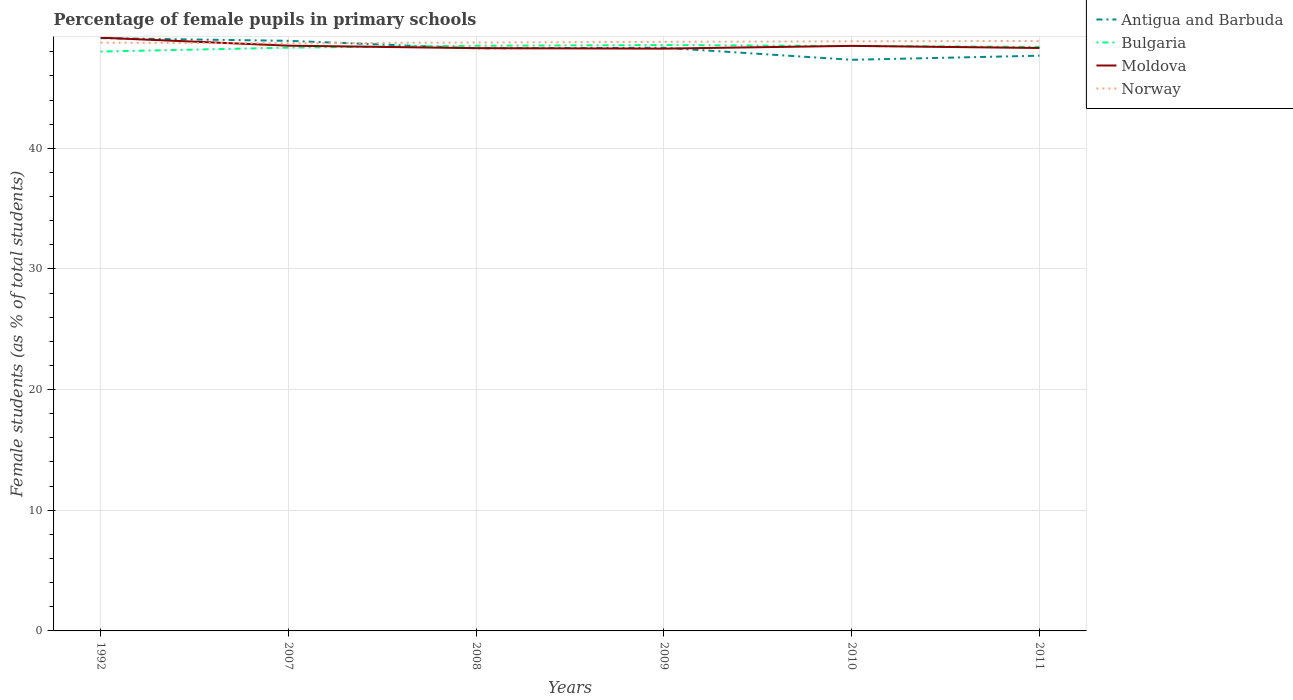How many different coloured lines are there?
Offer a very short reply. 4. Does the line corresponding to Moldova intersect with the line corresponding to Norway?
Offer a terse response. Yes. Across all years, what is the maximum percentage of female pupils in primary schools in Norway?
Your answer should be very brief. 48.7. In which year was the percentage of female pupils in primary schools in Bulgaria maximum?
Ensure brevity in your answer.  1992. What is the total percentage of female pupils in primary schools in Antigua and Barbuda in the graph?
Your answer should be very brief. 1.23. What is the difference between the highest and the second highest percentage of female pupils in primary schools in Antigua and Barbuda?
Your answer should be very brief. 1.79. What is the difference between the highest and the lowest percentage of female pupils in primary schools in Norway?
Your answer should be very brief. 3. Is the percentage of female pupils in primary schools in Norway strictly greater than the percentage of female pupils in primary schools in Moldova over the years?
Your answer should be compact. No. What is the difference between two consecutive major ticks on the Y-axis?
Provide a succinct answer. 10. Are the values on the major ticks of Y-axis written in scientific E-notation?
Keep it short and to the point. No. Does the graph contain any zero values?
Give a very brief answer. No. Does the graph contain grids?
Your response must be concise. Yes. Where does the legend appear in the graph?
Offer a terse response. Top right. How many legend labels are there?
Give a very brief answer. 4. What is the title of the graph?
Keep it short and to the point. Percentage of female pupils in primary schools. What is the label or title of the X-axis?
Your answer should be very brief. Years. What is the label or title of the Y-axis?
Make the answer very short. Female students (as % of total students). What is the Female students (as % of total students) in Antigua and Barbuda in 1992?
Your response must be concise. 49.13. What is the Female students (as % of total students) of Bulgaria in 1992?
Your response must be concise. 48.02. What is the Female students (as % of total students) of Moldova in 1992?
Your response must be concise. 49.17. What is the Female students (as % of total students) in Norway in 1992?
Offer a very short reply. 48.76. What is the Female students (as % of total students) in Antigua and Barbuda in 2007?
Make the answer very short. 48.91. What is the Female students (as % of total students) in Bulgaria in 2007?
Offer a very short reply. 48.34. What is the Female students (as % of total students) of Moldova in 2007?
Provide a succinct answer. 48.5. What is the Female students (as % of total students) in Norway in 2007?
Offer a very short reply. 48.7. What is the Female students (as % of total students) in Antigua and Barbuda in 2008?
Make the answer very short. 48.29. What is the Female students (as % of total students) of Bulgaria in 2008?
Your answer should be compact. 48.5. What is the Female students (as % of total students) in Moldova in 2008?
Give a very brief answer. 48.3. What is the Female students (as % of total students) of Norway in 2008?
Give a very brief answer. 48.77. What is the Female students (as % of total students) in Antigua and Barbuda in 2009?
Your answer should be very brief. 48.33. What is the Female students (as % of total students) in Bulgaria in 2009?
Your answer should be compact. 48.56. What is the Female students (as % of total students) in Moldova in 2009?
Ensure brevity in your answer.  48.26. What is the Female students (as % of total students) of Norway in 2009?
Provide a succinct answer. 48.82. What is the Female students (as % of total students) of Antigua and Barbuda in 2010?
Keep it short and to the point. 47.33. What is the Female students (as % of total students) of Bulgaria in 2010?
Keep it short and to the point. 48.48. What is the Female students (as % of total students) of Moldova in 2010?
Offer a terse response. 48.49. What is the Female students (as % of total students) in Norway in 2010?
Keep it short and to the point. 48.87. What is the Female students (as % of total students) in Antigua and Barbuda in 2011?
Offer a terse response. 47.67. What is the Female students (as % of total students) of Bulgaria in 2011?
Offer a terse response. 48.4. What is the Female students (as % of total students) in Moldova in 2011?
Offer a very short reply. 48.31. What is the Female students (as % of total students) in Norway in 2011?
Offer a very short reply. 48.9. Across all years, what is the maximum Female students (as % of total students) of Antigua and Barbuda?
Ensure brevity in your answer.  49.13. Across all years, what is the maximum Female students (as % of total students) in Bulgaria?
Give a very brief answer. 48.56. Across all years, what is the maximum Female students (as % of total students) in Moldova?
Offer a very short reply. 49.17. Across all years, what is the maximum Female students (as % of total students) in Norway?
Your response must be concise. 48.9. Across all years, what is the minimum Female students (as % of total students) of Antigua and Barbuda?
Offer a very short reply. 47.33. Across all years, what is the minimum Female students (as % of total students) in Bulgaria?
Offer a terse response. 48.02. Across all years, what is the minimum Female students (as % of total students) of Moldova?
Keep it short and to the point. 48.26. Across all years, what is the minimum Female students (as % of total students) in Norway?
Ensure brevity in your answer.  48.7. What is the total Female students (as % of total students) in Antigua and Barbuda in the graph?
Your response must be concise. 289.66. What is the total Female students (as % of total students) of Bulgaria in the graph?
Your response must be concise. 290.3. What is the total Female students (as % of total students) in Moldova in the graph?
Offer a terse response. 291.03. What is the total Female students (as % of total students) of Norway in the graph?
Your answer should be compact. 292.81. What is the difference between the Female students (as % of total students) of Antigua and Barbuda in 1992 and that in 2007?
Your answer should be compact. 0.22. What is the difference between the Female students (as % of total students) of Bulgaria in 1992 and that in 2007?
Keep it short and to the point. -0.32. What is the difference between the Female students (as % of total students) in Moldova in 1992 and that in 2007?
Your answer should be compact. 0.66. What is the difference between the Female students (as % of total students) of Norway in 1992 and that in 2007?
Give a very brief answer. 0.05. What is the difference between the Female students (as % of total students) of Antigua and Barbuda in 1992 and that in 2008?
Your answer should be compact. 0.84. What is the difference between the Female students (as % of total students) of Bulgaria in 1992 and that in 2008?
Your response must be concise. -0.48. What is the difference between the Female students (as % of total students) in Moldova in 1992 and that in 2008?
Provide a succinct answer. 0.87. What is the difference between the Female students (as % of total students) of Norway in 1992 and that in 2008?
Offer a terse response. -0.01. What is the difference between the Female students (as % of total students) of Antigua and Barbuda in 1992 and that in 2009?
Give a very brief answer. 0.8. What is the difference between the Female students (as % of total students) of Bulgaria in 1992 and that in 2009?
Offer a terse response. -0.54. What is the difference between the Female students (as % of total students) in Moldova in 1992 and that in 2009?
Give a very brief answer. 0.91. What is the difference between the Female students (as % of total students) of Norway in 1992 and that in 2009?
Make the answer very short. -0.07. What is the difference between the Female students (as % of total students) in Antigua and Barbuda in 1992 and that in 2010?
Your response must be concise. 1.79. What is the difference between the Female students (as % of total students) of Bulgaria in 1992 and that in 2010?
Make the answer very short. -0.46. What is the difference between the Female students (as % of total students) in Moldova in 1992 and that in 2010?
Your response must be concise. 0.68. What is the difference between the Female students (as % of total students) of Norway in 1992 and that in 2010?
Provide a succinct answer. -0.11. What is the difference between the Female students (as % of total students) in Antigua and Barbuda in 1992 and that in 2011?
Your response must be concise. 1.46. What is the difference between the Female students (as % of total students) in Bulgaria in 1992 and that in 2011?
Keep it short and to the point. -0.39. What is the difference between the Female students (as % of total students) in Moldova in 1992 and that in 2011?
Your answer should be compact. 0.85. What is the difference between the Female students (as % of total students) of Norway in 1992 and that in 2011?
Offer a terse response. -0.14. What is the difference between the Female students (as % of total students) in Antigua and Barbuda in 2007 and that in 2008?
Offer a very short reply. 0.62. What is the difference between the Female students (as % of total students) of Bulgaria in 2007 and that in 2008?
Ensure brevity in your answer.  -0.16. What is the difference between the Female students (as % of total students) of Moldova in 2007 and that in 2008?
Your answer should be very brief. 0.21. What is the difference between the Female students (as % of total students) in Norway in 2007 and that in 2008?
Offer a very short reply. -0.06. What is the difference between the Female students (as % of total students) in Antigua and Barbuda in 2007 and that in 2009?
Offer a very short reply. 0.57. What is the difference between the Female students (as % of total students) in Bulgaria in 2007 and that in 2009?
Your answer should be compact. -0.22. What is the difference between the Female students (as % of total students) of Moldova in 2007 and that in 2009?
Offer a terse response. 0.24. What is the difference between the Female students (as % of total students) in Norway in 2007 and that in 2009?
Give a very brief answer. -0.12. What is the difference between the Female students (as % of total students) of Antigua and Barbuda in 2007 and that in 2010?
Offer a terse response. 1.57. What is the difference between the Female students (as % of total students) of Bulgaria in 2007 and that in 2010?
Keep it short and to the point. -0.14. What is the difference between the Female students (as % of total students) in Moldova in 2007 and that in 2010?
Provide a succinct answer. 0.02. What is the difference between the Female students (as % of total students) in Norway in 2007 and that in 2010?
Your answer should be very brief. -0.17. What is the difference between the Female students (as % of total students) in Antigua and Barbuda in 2007 and that in 2011?
Keep it short and to the point. 1.23. What is the difference between the Female students (as % of total students) in Bulgaria in 2007 and that in 2011?
Your response must be concise. -0.07. What is the difference between the Female students (as % of total students) of Moldova in 2007 and that in 2011?
Give a very brief answer. 0.19. What is the difference between the Female students (as % of total students) of Norway in 2007 and that in 2011?
Make the answer very short. -0.19. What is the difference between the Female students (as % of total students) of Antigua and Barbuda in 2008 and that in 2009?
Offer a terse response. -0.05. What is the difference between the Female students (as % of total students) in Bulgaria in 2008 and that in 2009?
Offer a very short reply. -0.06. What is the difference between the Female students (as % of total students) of Moldova in 2008 and that in 2009?
Keep it short and to the point. 0.04. What is the difference between the Female students (as % of total students) of Norway in 2008 and that in 2009?
Offer a terse response. -0.06. What is the difference between the Female students (as % of total students) of Antigua and Barbuda in 2008 and that in 2010?
Your response must be concise. 0.95. What is the difference between the Female students (as % of total students) of Bulgaria in 2008 and that in 2010?
Make the answer very short. 0.02. What is the difference between the Female students (as % of total students) of Moldova in 2008 and that in 2010?
Make the answer very short. -0.19. What is the difference between the Female students (as % of total students) in Norway in 2008 and that in 2010?
Make the answer very short. -0.1. What is the difference between the Female students (as % of total students) in Antigua and Barbuda in 2008 and that in 2011?
Give a very brief answer. 0.61. What is the difference between the Female students (as % of total students) of Bulgaria in 2008 and that in 2011?
Keep it short and to the point. 0.1. What is the difference between the Female students (as % of total students) in Moldova in 2008 and that in 2011?
Ensure brevity in your answer.  -0.01. What is the difference between the Female students (as % of total students) in Norway in 2008 and that in 2011?
Provide a short and direct response. -0.13. What is the difference between the Female students (as % of total students) of Bulgaria in 2009 and that in 2010?
Make the answer very short. 0.08. What is the difference between the Female students (as % of total students) of Moldova in 2009 and that in 2010?
Ensure brevity in your answer.  -0.23. What is the difference between the Female students (as % of total students) of Norway in 2009 and that in 2010?
Keep it short and to the point. -0.05. What is the difference between the Female students (as % of total students) in Antigua and Barbuda in 2009 and that in 2011?
Make the answer very short. 0.66. What is the difference between the Female students (as % of total students) in Bulgaria in 2009 and that in 2011?
Your answer should be compact. 0.15. What is the difference between the Female students (as % of total students) of Moldova in 2009 and that in 2011?
Ensure brevity in your answer.  -0.05. What is the difference between the Female students (as % of total students) of Norway in 2009 and that in 2011?
Provide a short and direct response. -0.07. What is the difference between the Female students (as % of total students) of Antigua and Barbuda in 2010 and that in 2011?
Give a very brief answer. -0.34. What is the difference between the Female students (as % of total students) in Bulgaria in 2010 and that in 2011?
Offer a terse response. 0.07. What is the difference between the Female students (as % of total students) in Moldova in 2010 and that in 2011?
Offer a terse response. 0.17. What is the difference between the Female students (as % of total students) in Norway in 2010 and that in 2011?
Your answer should be compact. -0.03. What is the difference between the Female students (as % of total students) of Antigua and Barbuda in 1992 and the Female students (as % of total students) of Bulgaria in 2007?
Your response must be concise. 0.79. What is the difference between the Female students (as % of total students) in Antigua and Barbuda in 1992 and the Female students (as % of total students) in Moldova in 2007?
Make the answer very short. 0.62. What is the difference between the Female students (as % of total students) of Antigua and Barbuda in 1992 and the Female students (as % of total students) of Norway in 2007?
Provide a succinct answer. 0.43. What is the difference between the Female students (as % of total students) of Bulgaria in 1992 and the Female students (as % of total students) of Moldova in 2007?
Provide a short and direct response. -0.49. What is the difference between the Female students (as % of total students) of Bulgaria in 1992 and the Female students (as % of total students) of Norway in 2007?
Offer a terse response. -0.68. What is the difference between the Female students (as % of total students) of Moldova in 1992 and the Female students (as % of total students) of Norway in 2007?
Your answer should be compact. 0.46. What is the difference between the Female students (as % of total students) of Antigua and Barbuda in 1992 and the Female students (as % of total students) of Bulgaria in 2008?
Offer a very short reply. 0.63. What is the difference between the Female students (as % of total students) of Antigua and Barbuda in 1992 and the Female students (as % of total students) of Moldova in 2008?
Give a very brief answer. 0.83. What is the difference between the Female students (as % of total students) in Antigua and Barbuda in 1992 and the Female students (as % of total students) in Norway in 2008?
Offer a very short reply. 0.36. What is the difference between the Female students (as % of total students) in Bulgaria in 1992 and the Female students (as % of total students) in Moldova in 2008?
Offer a terse response. -0.28. What is the difference between the Female students (as % of total students) in Bulgaria in 1992 and the Female students (as % of total students) in Norway in 2008?
Offer a terse response. -0.75. What is the difference between the Female students (as % of total students) of Moldova in 1992 and the Female students (as % of total students) of Norway in 2008?
Offer a terse response. 0.4. What is the difference between the Female students (as % of total students) of Antigua and Barbuda in 1992 and the Female students (as % of total students) of Bulgaria in 2009?
Give a very brief answer. 0.57. What is the difference between the Female students (as % of total students) in Antigua and Barbuda in 1992 and the Female students (as % of total students) in Moldova in 2009?
Give a very brief answer. 0.87. What is the difference between the Female students (as % of total students) in Antigua and Barbuda in 1992 and the Female students (as % of total students) in Norway in 2009?
Give a very brief answer. 0.31. What is the difference between the Female students (as % of total students) of Bulgaria in 1992 and the Female students (as % of total students) of Moldova in 2009?
Keep it short and to the point. -0.24. What is the difference between the Female students (as % of total students) in Bulgaria in 1992 and the Female students (as % of total students) in Norway in 2009?
Offer a very short reply. -0.8. What is the difference between the Female students (as % of total students) in Moldova in 1992 and the Female students (as % of total students) in Norway in 2009?
Keep it short and to the point. 0.34. What is the difference between the Female students (as % of total students) in Antigua and Barbuda in 1992 and the Female students (as % of total students) in Bulgaria in 2010?
Ensure brevity in your answer.  0.65. What is the difference between the Female students (as % of total students) in Antigua and Barbuda in 1992 and the Female students (as % of total students) in Moldova in 2010?
Make the answer very short. 0.64. What is the difference between the Female students (as % of total students) in Antigua and Barbuda in 1992 and the Female students (as % of total students) in Norway in 2010?
Make the answer very short. 0.26. What is the difference between the Female students (as % of total students) in Bulgaria in 1992 and the Female students (as % of total students) in Moldova in 2010?
Your answer should be very brief. -0.47. What is the difference between the Female students (as % of total students) in Bulgaria in 1992 and the Female students (as % of total students) in Norway in 2010?
Offer a very short reply. -0.85. What is the difference between the Female students (as % of total students) of Moldova in 1992 and the Female students (as % of total students) of Norway in 2010?
Your response must be concise. 0.3. What is the difference between the Female students (as % of total students) in Antigua and Barbuda in 1992 and the Female students (as % of total students) in Bulgaria in 2011?
Give a very brief answer. 0.72. What is the difference between the Female students (as % of total students) in Antigua and Barbuda in 1992 and the Female students (as % of total students) in Moldova in 2011?
Your answer should be very brief. 0.82. What is the difference between the Female students (as % of total students) in Antigua and Barbuda in 1992 and the Female students (as % of total students) in Norway in 2011?
Offer a terse response. 0.23. What is the difference between the Female students (as % of total students) of Bulgaria in 1992 and the Female students (as % of total students) of Moldova in 2011?
Your answer should be compact. -0.29. What is the difference between the Female students (as % of total students) of Bulgaria in 1992 and the Female students (as % of total students) of Norway in 2011?
Provide a succinct answer. -0.88. What is the difference between the Female students (as % of total students) in Moldova in 1992 and the Female students (as % of total students) in Norway in 2011?
Your response must be concise. 0.27. What is the difference between the Female students (as % of total students) in Antigua and Barbuda in 2007 and the Female students (as % of total students) in Bulgaria in 2008?
Provide a short and direct response. 0.41. What is the difference between the Female students (as % of total students) of Antigua and Barbuda in 2007 and the Female students (as % of total students) of Moldova in 2008?
Provide a short and direct response. 0.61. What is the difference between the Female students (as % of total students) in Antigua and Barbuda in 2007 and the Female students (as % of total students) in Norway in 2008?
Provide a succinct answer. 0.14. What is the difference between the Female students (as % of total students) in Bulgaria in 2007 and the Female students (as % of total students) in Moldova in 2008?
Your response must be concise. 0.04. What is the difference between the Female students (as % of total students) of Bulgaria in 2007 and the Female students (as % of total students) of Norway in 2008?
Offer a terse response. -0.43. What is the difference between the Female students (as % of total students) of Moldova in 2007 and the Female students (as % of total students) of Norway in 2008?
Offer a very short reply. -0.26. What is the difference between the Female students (as % of total students) in Antigua and Barbuda in 2007 and the Female students (as % of total students) in Bulgaria in 2009?
Keep it short and to the point. 0.35. What is the difference between the Female students (as % of total students) in Antigua and Barbuda in 2007 and the Female students (as % of total students) in Moldova in 2009?
Your answer should be very brief. 0.65. What is the difference between the Female students (as % of total students) in Antigua and Barbuda in 2007 and the Female students (as % of total students) in Norway in 2009?
Your response must be concise. 0.08. What is the difference between the Female students (as % of total students) in Bulgaria in 2007 and the Female students (as % of total students) in Moldova in 2009?
Keep it short and to the point. 0.08. What is the difference between the Female students (as % of total students) in Bulgaria in 2007 and the Female students (as % of total students) in Norway in 2009?
Your answer should be very brief. -0.48. What is the difference between the Female students (as % of total students) of Moldova in 2007 and the Female students (as % of total students) of Norway in 2009?
Ensure brevity in your answer.  -0.32. What is the difference between the Female students (as % of total students) in Antigua and Barbuda in 2007 and the Female students (as % of total students) in Bulgaria in 2010?
Your answer should be compact. 0.43. What is the difference between the Female students (as % of total students) of Antigua and Barbuda in 2007 and the Female students (as % of total students) of Moldova in 2010?
Offer a terse response. 0.42. What is the difference between the Female students (as % of total students) in Antigua and Barbuda in 2007 and the Female students (as % of total students) in Norway in 2010?
Give a very brief answer. 0.04. What is the difference between the Female students (as % of total students) in Bulgaria in 2007 and the Female students (as % of total students) in Moldova in 2010?
Give a very brief answer. -0.15. What is the difference between the Female students (as % of total students) of Bulgaria in 2007 and the Female students (as % of total students) of Norway in 2010?
Keep it short and to the point. -0.53. What is the difference between the Female students (as % of total students) in Moldova in 2007 and the Female students (as % of total students) in Norway in 2010?
Give a very brief answer. -0.36. What is the difference between the Female students (as % of total students) in Antigua and Barbuda in 2007 and the Female students (as % of total students) in Bulgaria in 2011?
Your answer should be compact. 0.5. What is the difference between the Female students (as % of total students) in Antigua and Barbuda in 2007 and the Female students (as % of total students) in Moldova in 2011?
Your response must be concise. 0.59. What is the difference between the Female students (as % of total students) of Antigua and Barbuda in 2007 and the Female students (as % of total students) of Norway in 2011?
Your answer should be very brief. 0.01. What is the difference between the Female students (as % of total students) in Bulgaria in 2007 and the Female students (as % of total students) in Moldova in 2011?
Offer a very short reply. 0.03. What is the difference between the Female students (as % of total students) of Bulgaria in 2007 and the Female students (as % of total students) of Norway in 2011?
Your answer should be very brief. -0.56. What is the difference between the Female students (as % of total students) of Moldova in 2007 and the Female students (as % of total students) of Norway in 2011?
Your response must be concise. -0.39. What is the difference between the Female students (as % of total students) in Antigua and Barbuda in 2008 and the Female students (as % of total students) in Bulgaria in 2009?
Make the answer very short. -0.27. What is the difference between the Female students (as % of total students) in Antigua and Barbuda in 2008 and the Female students (as % of total students) in Moldova in 2009?
Ensure brevity in your answer.  0.03. What is the difference between the Female students (as % of total students) in Antigua and Barbuda in 2008 and the Female students (as % of total students) in Norway in 2009?
Give a very brief answer. -0.53. What is the difference between the Female students (as % of total students) in Bulgaria in 2008 and the Female students (as % of total students) in Moldova in 2009?
Make the answer very short. 0.24. What is the difference between the Female students (as % of total students) in Bulgaria in 2008 and the Female students (as % of total students) in Norway in 2009?
Keep it short and to the point. -0.32. What is the difference between the Female students (as % of total students) in Moldova in 2008 and the Female students (as % of total students) in Norway in 2009?
Provide a succinct answer. -0.52. What is the difference between the Female students (as % of total students) in Antigua and Barbuda in 2008 and the Female students (as % of total students) in Bulgaria in 2010?
Offer a very short reply. -0.19. What is the difference between the Female students (as % of total students) of Antigua and Barbuda in 2008 and the Female students (as % of total students) of Moldova in 2010?
Your answer should be very brief. -0.2. What is the difference between the Female students (as % of total students) in Antigua and Barbuda in 2008 and the Female students (as % of total students) in Norway in 2010?
Provide a succinct answer. -0.58. What is the difference between the Female students (as % of total students) of Bulgaria in 2008 and the Female students (as % of total students) of Moldova in 2010?
Your answer should be compact. 0.01. What is the difference between the Female students (as % of total students) in Bulgaria in 2008 and the Female students (as % of total students) in Norway in 2010?
Your answer should be compact. -0.37. What is the difference between the Female students (as % of total students) in Moldova in 2008 and the Female students (as % of total students) in Norway in 2010?
Offer a very short reply. -0.57. What is the difference between the Female students (as % of total students) in Antigua and Barbuda in 2008 and the Female students (as % of total students) in Bulgaria in 2011?
Keep it short and to the point. -0.12. What is the difference between the Female students (as % of total students) in Antigua and Barbuda in 2008 and the Female students (as % of total students) in Moldova in 2011?
Make the answer very short. -0.03. What is the difference between the Female students (as % of total students) of Antigua and Barbuda in 2008 and the Female students (as % of total students) of Norway in 2011?
Offer a very short reply. -0.61. What is the difference between the Female students (as % of total students) in Bulgaria in 2008 and the Female students (as % of total students) in Moldova in 2011?
Your answer should be compact. 0.19. What is the difference between the Female students (as % of total students) in Bulgaria in 2008 and the Female students (as % of total students) in Norway in 2011?
Provide a succinct answer. -0.4. What is the difference between the Female students (as % of total students) in Moldova in 2008 and the Female students (as % of total students) in Norway in 2011?
Ensure brevity in your answer.  -0.6. What is the difference between the Female students (as % of total students) of Antigua and Barbuda in 2009 and the Female students (as % of total students) of Bulgaria in 2010?
Offer a very short reply. -0.14. What is the difference between the Female students (as % of total students) of Antigua and Barbuda in 2009 and the Female students (as % of total students) of Moldova in 2010?
Ensure brevity in your answer.  -0.15. What is the difference between the Female students (as % of total students) in Antigua and Barbuda in 2009 and the Female students (as % of total students) in Norway in 2010?
Your answer should be very brief. -0.54. What is the difference between the Female students (as % of total students) of Bulgaria in 2009 and the Female students (as % of total students) of Moldova in 2010?
Provide a short and direct response. 0.07. What is the difference between the Female students (as % of total students) of Bulgaria in 2009 and the Female students (as % of total students) of Norway in 2010?
Give a very brief answer. -0.31. What is the difference between the Female students (as % of total students) in Moldova in 2009 and the Female students (as % of total students) in Norway in 2010?
Offer a terse response. -0.61. What is the difference between the Female students (as % of total students) in Antigua and Barbuda in 2009 and the Female students (as % of total students) in Bulgaria in 2011?
Provide a succinct answer. -0.07. What is the difference between the Female students (as % of total students) of Antigua and Barbuda in 2009 and the Female students (as % of total students) of Moldova in 2011?
Ensure brevity in your answer.  0.02. What is the difference between the Female students (as % of total students) in Antigua and Barbuda in 2009 and the Female students (as % of total students) in Norway in 2011?
Give a very brief answer. -0.56. What is the difference between the Female students (as % of total students) in Bulgaria in 2009 and the Female students (as % of total students) in Moldova in 2011?
Provide a short and direct response. 0.25. What is the difference between the Female students (as % of total students) in Bulgaria in 2009 and the Female students (as % of total students) in Norway in 2011?
Your answer should be very brief. -0.34. What is the difference between the Female students (as % of total students) of Moldova in 2009 and the Female students (as % of total students) of Norway in 2011?
Offer a terse response. -0.64. What is the difference between the Female students (as % of total students) of Antigua and Barbuda in 2010 and the Female students (as % of total students) of Bulgaria in 2011?
Make the answer very short. -1.07. What is the difference between the Female students (as % of total students) of Antigua and Barbuda in 2010 and the Female students (as % of total students) of Moldova in 2011?
Your response must be concise. -0.98. What is the difference between the Female students (as % of total students) of Antigua and Barbuda in 2010 and the Female students (as % of total students) of Norway in 2011?
Offer a very short reply. -1.56. What is the difference between the Female students (as % of total students) in Bulgaria in 2010 and the Female students (as % of total students) in Moldova in 2011?
Offer a very short reply. 0.16. What is the difference between the Female students (as % of total students) in Bulgaria in 2010 and the Female students (as % of total students) in Norway in 2011?
Your response must be concise. -0.42. What is the difference between the Female students (as % of total students) of Moldova in 2010 and the Female students (as % of total students) of Norway in 2011?
Provide a short and direct response. -0.41. What is the average Female students (as % of total students) of Antigua and Barbuda per year?
Give a very brief answer. 48.28. What is the average Female students (as % of total students) of Bulgaria per year?
Provide a succinct answer. 48.38. What is the average Female students (as % of total students) of Moldova per year?
Your response must be concise. 48.51. What is the average Female students (as % of total students) in Norway per year?
Your answer should be very brief. 48.8. In the year 1992, what is the difference between the Female students (as % of total students) of Antigua and Barbuda and Female students (as % of total students) of Bulgaria?
Offer a terse response. 1.11. In the year 1992, what is the difference between the Female students (as % of total students) of Antigua and Barbuda and Female students (as % of total students) of Moldova?
Your answer should be compact. -0.04. In the year 1992, what is the difference between the Female students (as % of total students) in Antigua and Barbuda and Female students (as % of total students) in Norway?
Make the answer very short. 0.37. In the year 1992, what is the difference between the Female students (as % of total students) in Bulgaria and Female students (as % of total students) in Moldova?
Give a very brief answer. -1.15. In the year 1992, what is the difference between the Female students (as % of total students) of Bulgaria and Female students (as % of total students) of Norway?
Your response must be concise. -0.74. In the year 1992, what is the difference between the Female students (as % of total students) in Moldova and Female students (as % of total students) in Norway?
Offer a terse response. 0.41. In the year 2007, what is the difference between the Female students (as % of total students) in Antigua and Barbuda and Female students (as % of total students) in Bulgaria?
Offer a terse response. 0.57. In the year 2007, what is the difference between the Female students (as % of total students) of Antigua and Barbuda and Female students (as % of total students) of Moldova?
Your answer should be compact. 0.4. In the year 2007, what is the difference between the Female students (as % of total students) of Antigua and Barbuda and Female students (as % of total students) of Norway?
Your answer should be very brief. 0.2. In the year 2007, what is the difference between the Female students (as % of total students) of Bulgaria and Female students (as % of total students) of Moldova?
Ensure brevity in your answer.  -0.17. In the year 2007, what is the difference between the Female students (as % of total students) in Bulgaria and Female students (as % of total students) in Norway?
Offer a very short reply. -0.36. In the year 2007, what is the difference between the Female students (as % of total students) of Moldova and Female students (as % of total students) of Norway?
Offer a terse response. -0.2. In the year 2008, what is the difference between the Female students (as % of total students) of Antigua and Barbuda and Female students (as % of total students) of Bulgaria?
Offer a very short reply. -0.21. In the year 2008, what is the difference between the Female students (as % of total students) in Antigua and Barbuda and Female students (as % of total students) in Moldova?
Your answer should be compact. -0.01. In the year 2008, what is the difference between the Female students (as % of total students) in Antigua and Barbuda and Female students (as % of total students) in Norway?
Your answer should be very brief. -0.48. In the year 2008, what is the difference between the Female students (as % of total students) of Bulgaria and Female students (as % of total students) of Moldova?
Ensure brevity in your answer.  0.2. In the year 2008, what is the difference between the Female students (as % of total students) in Bulgaria and Female students (as % of total students) in Norway?
Provide a succinct answer. -0.27. In the year 2008, what is the difference between the Female students (as % of total students) in Moldova and Female students (as % of total students) in Norway?
Provide a short and direct response. -0.47. In the year 2009, what is the difference between the Female students (as % of total students) in Antigua and Barbuda and Female students (as % of total students) in Bulgaria?
Provide a short and direct response. -0.23. In the year 2009, what is the difference between the Female students (as % of total students) in Antigua and Barbuda and Female students (as % of total students) in Moldova?
Keep it short and to the point. 0.07. In the year 2009, what is the difference between the Female students (as % of total students) in Antigua and Barbuda and Female students (as % of total students) in Norway?
Give a very brief answer. -0.49. In the year 2009, what is the difference between the Female students (as % of total students) in Bulgaria and Female students (as % of total students) in Moldova?
Your response must be concise. 0.3. In the year 2009, what is the difference between the Female students (as % of total students) in Bulgaria and Female students (as % of total students) in Norway?
Your answer should be compact. -0.26. In the year 2009, what is the difference between the Female students (as % of total students) of Moldova and Female students (as % of total students) of Norway?
Offer a very short reply. -0.56. In the year 2010, what is the difference between the Female students (as % of total students) of Antigua and Barbuda and Female students (as % of total students) of Bulgaria?
Your response must be concise. -1.14. In the year 2010, what is the difference between the Female students (as % of total students) in Antigua and Barbuda and Female students (as % of total students) in Moldova?
Make the answer very short. -1.15. In the year 2010, what is the difference between the Female students (as % of total students) in Antigua and Barbuda and Female students (as % of total students) in Norway?
Make the answer very short. -1.53. In the year 2010, what is the difference between the Female students (as % of total students) of Bulgaria and Female students (as % of total students) of Moldova?
Your response must be concise. -0.01. In the year 2010, what is the difference between the Female students (as % of total students) in Bulgaria and Female students (as % of total students) in Norway?
Your response must be concise. -0.39. In the year 2010, what is the difference between the Female students (as % of total students) of Moldova and Female students (as % of total students) of Norway?
Ensure brevity in your answer.  -0.38. In the year 2011, what is the difference between the Female students (as % of total students) of Antigua and Barbuda and Female students (as % of total students) of Bulgaria?
Ensure brevity in your answer.  -0.73. In the year 2011, what is the difference between the Female students (as % of total students) in Antigua and Barbuda and Female students (as % of total students) in Moldova?
Ensure brevity in your answer.  -0.64. In the year 2011, what is the difference between the Female students (as % of total students) in Antigua and Barbuda and Female students (as % of total students) in Norway?
Your answer should be compact. -1.22. In the year 2011, what is the difference between the Female students (as % of total students) of Bulgaria and Female students (as % of total students) of Moldova?
Give a very brief answer. 0.09. In the year 2011, what is the difference between the Female students (as % of total students) of Bulgaria and Female students (as % of total students) of Norway?
Offer a very short reply. -0.49. In the year 2011, what is the difference between the Female students (as % of total students) in Moldova and Female students (as % of total students) in Norway?
Offer a very short reply. -0.58. What is the ratio of the Female students (as % of total students) in Moldova in 1992 to that in 2007?
Keep it short and to the point. 1.01. What is the ratio of the Female students (as % of total students) in Norway in 1992 to that in 2007?
Keep it short and to the point. 1. What is the ratio of the Female students (as % of total students) in Antigua and Barbuda in 1992 to that in 2008?
Your response must be concise. 1.02. What is the ratio of the Female students (as % of total students) in Bulgaria in 1992 to that in 2008?
Keep it short and to the point. 0.99. What is the ratio of the Female students (as % of total students) of Antigua and Barbuda in 1992 to that in 2009?
Keep it short and to the point. 1.02. What is the ratio of the Female students (as % of total students) in Bulgaria in 1992 to that in 2009?
Your answer should be very brief. 0.99. What is the ratio of the Female students (as % of total students) in Moldova in 1992 to that in 2009?
Your answer should be very brief. 1.02. What is the ratio of the Female students (as % of total students) of Norway in 1992 to that in 2009?
Ensure brevity in your answer.  1. What is the ratio of the Female students (as % of total students) of Antigua and Barbuda in 1992 to that in 2010?
Offer a terse response. 1.04. What is the ratio of the Female students (as % of total students) in Bulgaria in 1992 to that in 2010?
Your response must be concise. 0.99. What is the ratio of the Female students (as % of total students) in Antigua and Barbuda in 1992 to that in 2011?
Your answer should be compact. 1.03. What is the ratio of the Female students (as % of total students) of Moldova in 1992 to that in 2011?
Offer a very short reply. 1.02. What is the ratio of the Female students (as % of total students) of Antigua and Barbuda in 2007 to that in 2008?
Ensure brevity in your answer.  1.01. What is the ratio of the Female students (as % of total students) of Bulgaria in 2007 to that in 2008?
Ensure brevity in your answer.  1. What is the ratio of the Female students (as % of total students) of Antigua and Barbuda in 2007 to that in 2009?
Give a very brief answer. 1.01. What is the ratio of the Female students (as % of total students) of Norway in 2007 to that in 2009?
Give a very brief answer. 1. What is the ratio of the Female students (as % of total students) in Antigua and Barbuda in 2007 to that in 2010?
Make the answer very short. 1.03. What is the ratio of the Female students (as % of total students) in Bulgaria in 2007 to that in 2010?
Provide a succinct answer. 1. What is the ratio of the Female students (as % of total students) of Antigua and Barbuda in 2007 to that in 2011?
Your answer should be very brief. 1.03. What is the ratio of the Female students (as % of total students) of Norway in 2007 to that in 2011?
Ensure brevity in your answer.  1. What is the ratio of the Female students (as % of total students) in Antigua and Barbuda in 2008 to that in 2009?
Your response must be concise. 1. What is the ratio of the Female students (as % of total students) in Bulgaria in 2008 to that in 2009?
Your answer should be compact. 1. What is the ratio of the Female students (as % of total students) of Moldova in 2008 to that in 2009?
Ensure brevity in your answer.  1. What is the ratio of the Female students (as % of total students) in Antigua and Barbuda in 2008 to that in 2010?
Provide a short and direct response. 1.02. What is the ratio of the Female students (as % of total students) in Bulgaria in 2008 to that in 2010?
Ensure brevity in your answer.  1. What is the ratio of the Female students (as % of total students) of Moldova in 2008 to that in 2010?
Give a very brief answer. 1. What is the ratio of the Female students (as % of total students) in Norway in 2008 to that in 2010?
Ensure brevity in your answer.  1. What is the ratio of the Female students (as % of total students) in Antigua and Barbuda in 2008 to that in 2011?
Make the answer very short. 1.01. What is the ratio of the Female students (as % of total students) in Bulgaria in 2008 to that in 2011?
Keep it short and to the point. 1. What is the ratio of the Female students (as % of total students) of Norway in 2008 to that in 2011?
Your answer should be very brief. 1. What is the ratio of the Female students (as % of total students) in Antigua and Barbuda in 2009 to that in 2010?
Your response must be concise. 1.02. What is the ratio of the Female students (as % of total students) of Moldova in 2009 to that in 2010?
Provide a succinct answer. 1. What is the ratio of the Female students (as % of total students) of Antigua and Barbuda in 2009 to that in 2011?
Your answer should be compact. 1.01. What is the ratio of the Female students (as % of total students) in Bulgaria in 2009 to that in 2011?
Your answer should be very brief. 1. What is the ratio of the Female students (as % of total students) of Moldova in 2009 to that in 2011?
Give a very brief answer. 1. What is the ratio of the Female students (as % of total students) in Antigua and Barbuda in 2010 to that in 2011?
Give a very brief answer. 0.99. What is the ratio of the Female students (as % of total students) in Bulgaria in 2010 to that in 2011?
Provide a short and direct response. 1. What is the ratio of the Female students (as % of total students) in Norway in 2010 to that in 2011?
Keep it short and to the point. 1. What is the difference between the highest and the second highest Female students (as % of total students) of Antigua and Barbuda?
Provide a succinct answer. 0.22. What is the difference between the highest and the second highest Female students (as % of total students) in Bulgaria?
Ensure brevity in your answer.  0.06. What is the difference between the highest and the second highest Female students (as % of total students) of Moldova?
Offer a terse response. 0.66. What is the difference between the highest and the second highest Female students (as % of total students) of Norway?
Provide a succinct answer. 0.03. What is the difference between the highest and the lowest Female students (as % of total students) in Antigua and Barbuda?
Make the answer very short. 1.79. What is the difference between the highest and the lowest Female students (as % of total students) of Bulgaria?
Offer a terse response. 0.54. What is the difference between the highest and the lowest Female students (as % of total students) of Moldova?
Your response must be concise. 0.91. What is the difference between the highest and the lowest Female students (as % of total students) of Norway?
Give a very brief answer. 0.19. 